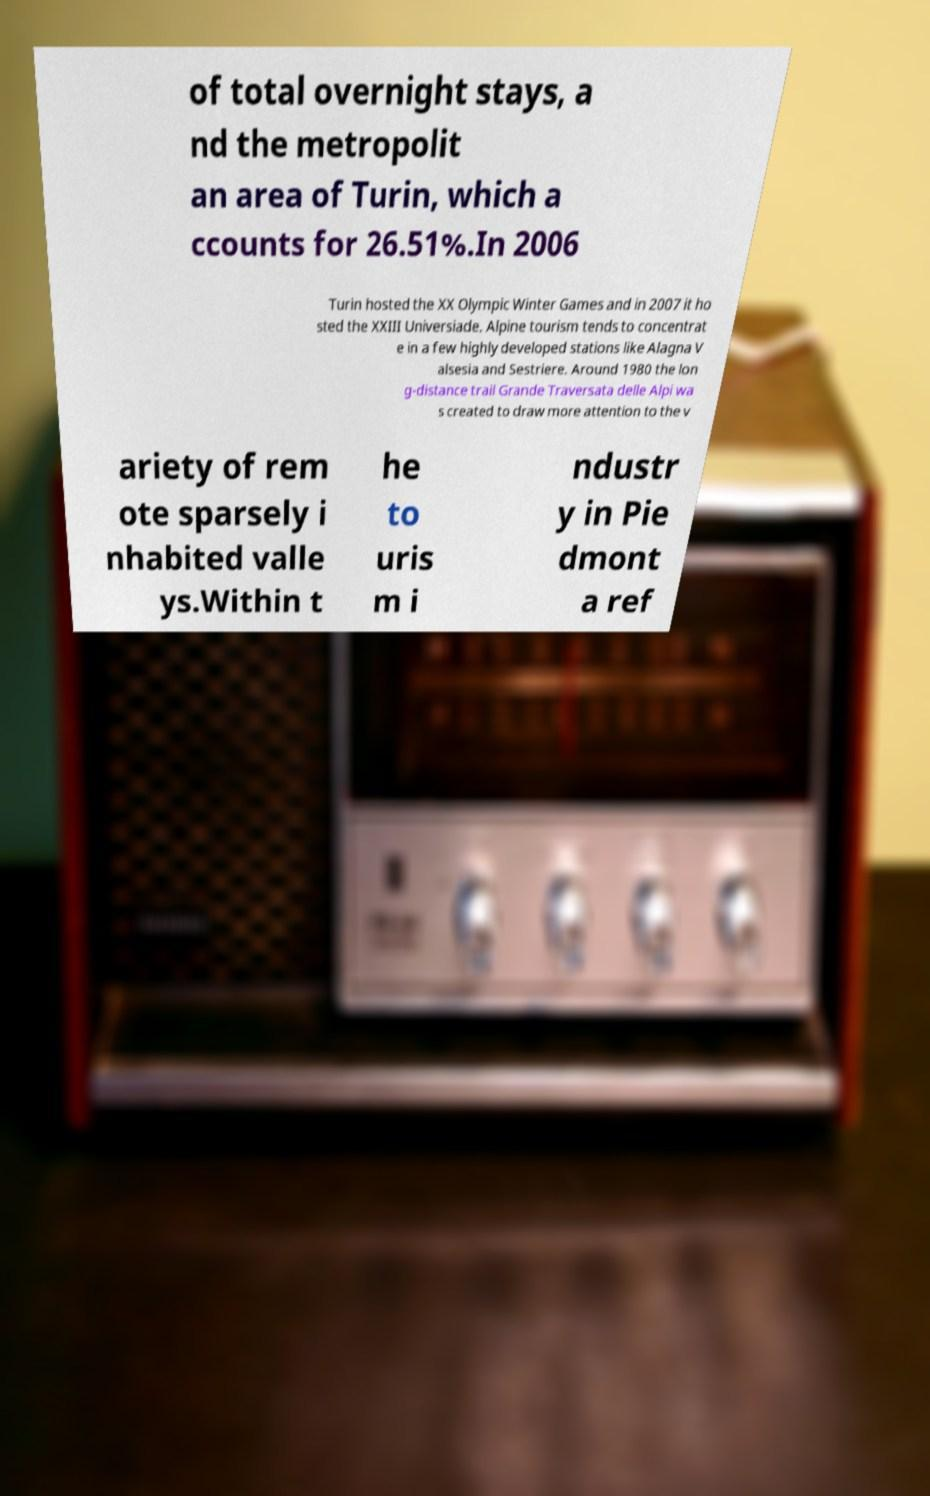Could you extract and type out the text from this image? of total overnight stays, a nd the metropolit an area of Turin, which a ccounts for 26.51%.In 2006 Turin hosted the XX Olympic Winter Games and in 2007 it ho sted the XXIII Universiade. Alpine tourism tends to concentrat e in a few highly developed stations like Alagna V alsesia and Sestriere. Around 1980 the lon g-distance trail Grande Traversata delle Alpi wa s created to draw more attention to the v ariety of rem ote sparsely i nhabited valle ys.Within t he to uris m i ndustr y in Pie dmont a ref 